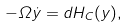<formula> <loc_0><loc_0><loc_500><loc_500>- \Omega \dot { y } = d H _ { C } ( y ) ,</formula> 